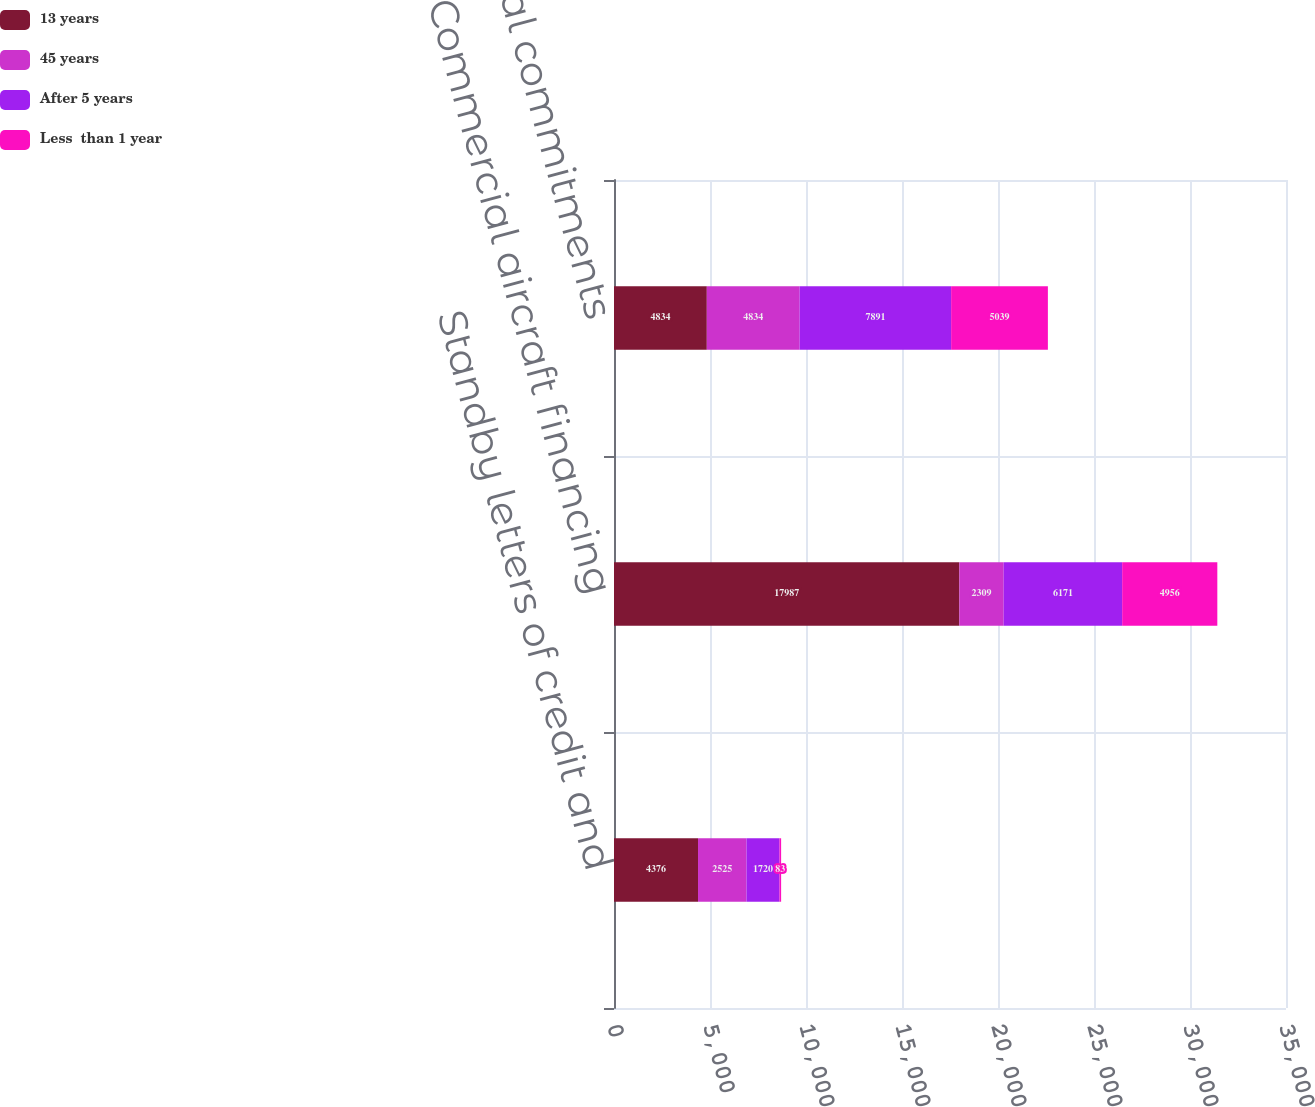Convert chart. <chart><loc_0><loc_0><loc_500><loc_500><stacked_bar_chart><ecel><fcel>Standby letters of credit and<fcel>Commercial aircraft financing<fcel>Total commercial commitments<nl><fcel>13 years<fcel>4376<fcel>17987<fcel>4834<nl><fcel>45 years<fcel>2525<fcel>2309<fcel>4834<nl><fcel>After 5 years<fcel>1720<fcel>6171<fcel>7891<nl><fcel>Less  than 1 year<fcel>83<fcel>4956<fcel>5039<nl></chart> 